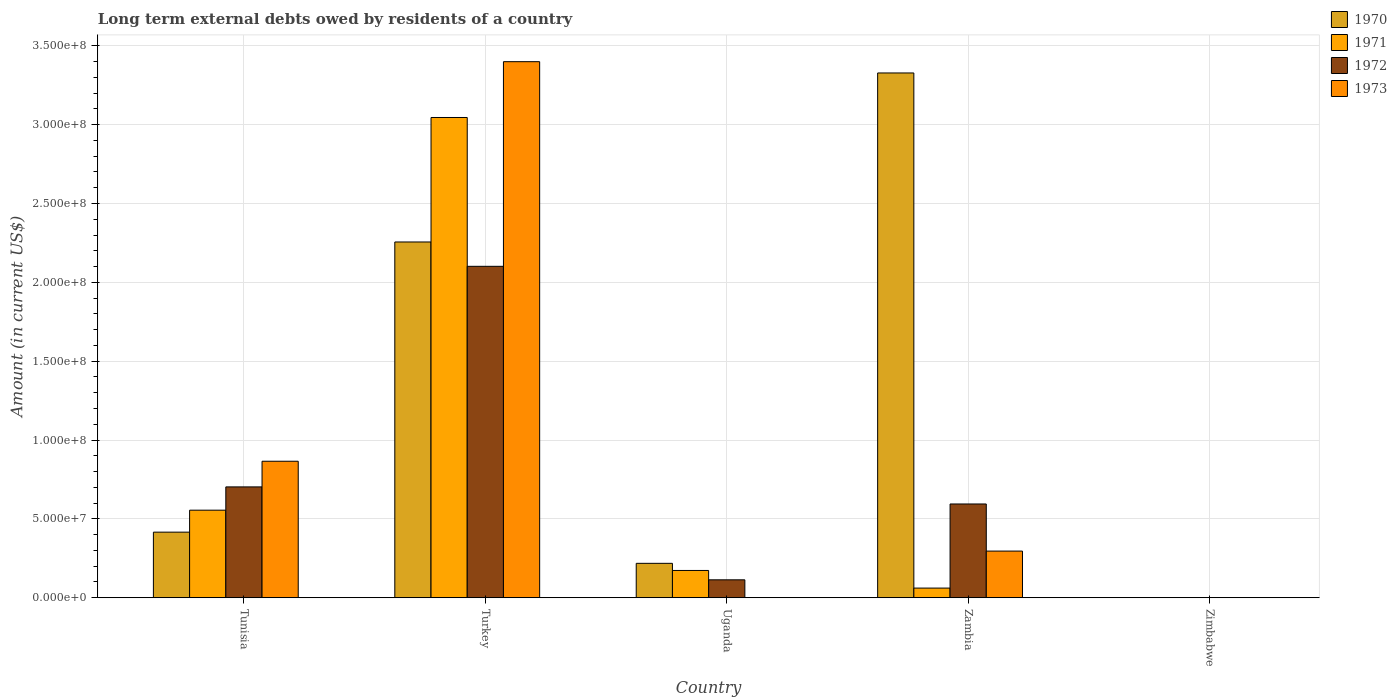How many different coloured bars are there?
Keep it short and to the point. 4. How many bars are there on the 3rd tick from the right?
Your response must be concise. 3. What is the label of the 5th group of bars from the left?
Make the answer very short. Zimbabwe. In how many cases, is the number of bars for a given country not equal to the number of legend labels?
Your answer should be very brief. 2. What is the amount of long-term external debts owed by residents in 1972 in Turkey?
Your answer should be very brief. 2.10e+08. Across all countries, what is the maximum amount of long-term external debts owed by residents in 1971?
Provide a short and direct response. 3.05e+08. Across all countries, what is the minimum amount of long-term external debts owed by residents in 1973?
Provide a short and direct response. 0. In which country was the amount of long-term external debts owed by residents in 1970 maximum?
Your response must be concise. Zambia. What is the total amount of long-term external debts owed by residents in 1971 in the graph?
Offer a terse response. 3.84e+08. What is the difference between the amount of long-term external debts owed by residents in 1972 in Uganda and that in Zambia?
Your answer should be compact. -4.81e+07. What is the difference between the amount of long-term external debts owed by residents in 1972 in Turkey and the amount of long-term external debts owed by residents in 1971 in Tunisia?
Your answer should be compact. 1.55e+08. What is the average amount of long-term external debts owed by residents in 1972 per country?
Offer a terse response. 7.03e+07. What is the difference between the amount of long-term external debts owed by residents of/in 1973 and amount of long-term external debts owed by residents of/in 1972 in Zambia?
Ensure brevity in your answer.  -2.99e+07. In how many countries, is the amount of long-term external debts owed by residents in 1973 greater than 220000000 US$?
Ensure brevity in your answer.  1. What is the ratio of the amount of long-term external debts owed by residents in 1971 in Turkey to that in Uganda?
Offer a very short reply. 17.6. Is the difference between the amount of long-term external debts owed by residents in 1973 in Tunisia and Turkey greater than the difference between the amount of long-term external debts owed by residents in 1972 in Tunisia and Turkey?
Keep it short and to the point. No. What is the difference between the highest and the second highest amount of long-term external debts owed by residents in 1971?
Make the answer very short. 2.87e+08. What is the difference between the highest and the lowest amount of long-term external debts owed by residents in 1971?
Provide a short and direct response. 3.05e+08. Is the sum of the amount of long-term external debts owed by residents in 1970 in Turkey and Uganda greater than the maximum amount of long-term external debts owed by residents in 1972 across all countries?
Your answer should be very brief. Yes. Is it the case that in every country, the sum of the amount of long-term external debts owed by residents in 1970 and amount of long-term external debts owed by residents in 1971 is greater than the sum of amount of long-term external debts owed by residents in 1972 and amount of long-term external debts owed by residents in 1973?
Offer a very short reply. No. Is it the case that in every country, the sum of the amount of long-term external debts owed by residents in 1973 and amount of long-term external debts owed by residents in 1971 is greater than the amount of long-term external debts owed by residents in 1970?
Make the answer very short. No. How many bars are there?
Your answer should be compact. 15. Are all the bars in the graph horizontal?
Provide a succinct answer. No. Does the graph contain grids?
Your answer should be very brief. Yes. How are the legend labels stacked?
Ensure brevity in your answer.  Vertical. What is the title of the graph?
Your answer should be compact. Long term external debts owed by residents of a country. Does "2001" appear as one of the legend labels in the graph?
Ensure brevity in your answer.  No. What is the label or title of the X-axis?
Your response must be concise. Country. What is the Amount (in current US$) in 1970 in Tunisia?
Give a very brief answer. 4.16e+07. What is the Amount (in current US$) in 1971 in Tunisia?
Provide a succinct answer. 5.55e+07. What is the Amount (in current US$) in 1972 in Tunisia?
Your answer should be very brief. 7.03e+07. What is the Amount (in current US$) in 1973 in Tunisia?
Your answer should be compact. 8.66e+07. What is the Amount (in current US$) in 1970 in Turkey?
Keep it short and to the point. 2.26e+08. What is the Amount (in current US$) in 1971 in Turkey?
Offer a terse response. 3.05e+08. What is the Amount (in current US$) in 1972 in Turkey?
Provide a succinct answer. 2.10e+08. What is the Amount (in current US$) of 1973 in Turkey?
Your response must be concise. 3.40e+08. What is the Amount (in current US$) in 1970 in Uganda?
Ensure brevity in your answer.  2.18e+07. What is the Amount (in current US$) of 1971 in Uganda?
Offer a terse response. 1.73e+07. What is the Amount (in current US$) in 1972 in Uganda?
Your answer should be compact. 1.14e+07. What is the Amount (in current US$) of 1973 in Uganda?
Ensure brevity in your answer.  0. What is the Amount (in current US$) of 1970 in Zambia?
Provide a short and direct response. 3.33e+08. What is the Amount (in current US$) of 1971 in Zambia?
Your answer should be compact. 6.13e+06. What is the Amount (in current US$) in 1972 in Zambia?
Your answer should be compact. 5.95e+07. What is the Amount (in current US$) of 1973 in Zambia?
Provide a succinct answer. 2.96e+07. What is the Amount (in current US$) of 1970 in Zimbabwe?
Your response must be concise. 0. What is the Amount (in current US$) in 1972 in Zimbabwe?
Provide a succinct answer. 0. Across all countries, what is the maximum Amount (in current US$) in 1970?
Your answer should be very brief. 3.33e+08. Across all countries, what is the maximum Amount (in current US$) in 1971?
Make the answer very short. 3.05e+08. Across all countries, what is the maximum Amount (in current US$) in 1972?
Ensure brevity in your answer.  2.10e+08. Across all countries, what is the maximum Amount (in current US$) in 1973?
Provide a succinct answer. 3.40e+08. Across all countries, what is the minimum Amount (in current US$) in 1970?
Make the answer very short. 0. Across all countries, what is the minimum Amount (in current US$) in 1971?
Keep it short and to the point. 0. Across all countries, what is the minimum Amount (in current US$) in 1972?
Offer a terse response. 0. What is the total Amount (in current US$) in 1970 in the graph?
Your answer should be very brief. 6.22e+08. What is the total Amount (in current US$) of 1971 in the graph?
Provide a succinct answer. 3.84e+08. What is the total Amount (in current US$) of 1972 in the graph?
Your answer should be very brief. 3.51e+08. What is the total Amount (in current US$) in 1973 in the graph?
Give a very brief answer. 4.56e+08. What is the difference between the Amount (in current US$) in 1970 in Tunisia and that in Turkey?
Offer a terse response. -1.84e+08. What is the difference between the Amount (in current US$) in 1971 in Tunisia and that in Turkey?
Offer a terse response. -2.49e+08. What is the difference between the Amount (in current US$) in 1972 in Tunisia and that in Turkey?
Offer a terse response. -1.40e+08. What is the difference between the Amount (in current US$) in 1973 in Tunisia and that in Turkey?
Ensure brevity in your answer.  -2.53e+08. What is the difference between the Amount (in current US$) of 1970 in Tunisia and that in Uganda?
Offer a very short reply. 1.98e+07. What is the difference between the Amount (in current US$) of 1971 in Tunisia and that in Uganda?
Provide a succinct answer. 3.82e+07. What is the difference between the Amount (in current US$) of 1972 in Tunisia and that in Uganda?
Your answer should be compact. 5.89e+07. What is the difference between the Amount (in current US$) of 1970 in Tunisia and that in Zambia?
Your answer should be very brief. -2.91e+08. What is the difference between the Amount (in current US$) of 1971 in Tunisia and that in Zambia?
Your response must be concise. 4.94e+07. What is the difference between the Amount (in current US$) of 1972 in Tunisia and that in Zambia?
Make the answer very short. 1.08e+07. What is the difference between the Amount (in current US$) of 1973 in Tunisia and that in Zambia?
Provide a succinct answer. 5.70e+07. What is the difference between the Amount (in current US$) of 1970 in Turkey and that in Uganda?
Give a very brief answer. 2.04e+08. What is the difference between the Amount (in current US$) in 1971 in Turkey and that in Uganda?
Your answer should be very brief. 2.87e+08. What is the difference between the Amount (in current US$) of 1972 in Turkey and that in Uganda?
Give a very brief answer. 1.99e+08. What is the difference between the Amount (in current US$) of 1970 in Turkey and that in Zambia?
Keep it short and to the point. -1.07e+08. What is the difference between the Amount (in current US$) of 1971 in Turkey and that in Zambia?
Provide a short and direct response. 2.98e+08. What is the difference between the Amount (in current US$) in 1972 in Turkey and that in Zambia?
Ensure brevity in your answer.  1.51e+08. What is the difference between the Amount (in current US$) of 1973 in Turkey and that in Zambia?
Your answer should be very brief. 3.10e+08. What is the difference between the Amount (in current US$) of 1970 in Uganda and that in Zambia?
Make the answer very short. -3.11e+08. What is the difference between the Amount (in current US$) of 1971 in Uganda and that in Zambia?
Make the answer very short. 1.12e+07. What is the difference between the Amount (in current US$) of 1972 in Uganda and that in Zambia?
Your response must be concise. -4.81e+07. What is the difference between the Amount (in current US$) of 1970 in Tunisia and the Amount (in current US$) of 1971 in Turkey?
Your response must be concise. -2.63e+08. What is the difference between the Amount (in current US$) in 1970 in Tunisia and the Amount (in current US$) in 1972 in Turkey?
Keep it short and to the point. -1.69e+08. What is the difference between the Amount (in current US$) of 1970 in Tunisia and the Amount (in current US$) of 1973 in Turkey?
Keep it short and to the point. -2.98e+08. What is the difference between the Amount (in current US$) of 1971 in Tunisia and the Amount (in current US$) of 1972 in Turkey?
Provide a succinct answer. -1.55e+08. What is the difference between the Amount (in current US$) in 1971 in Tunisia and the Amount (in current US$) in 1973 in Turkey?
Your response must be concise. -2.84e+08. What is the difference between the Amount (in current US$) in 1972 in Tunisia and the Amount (in current US$) in 1973 in Turkey?
Offer a terse response. -2.70e+08. What is the difference between the Amount (in current US$) in 1970 in Tunisia and the Amount (in current US$) in 1971 in Uganda?
Provide a short and direct response. 2.43e+07. What is the difference between the Amount (in current US$) of 1970 in Tunisia and the Amount (in current US$) of 1972 in Uganda?
Your response must be concise. 3.02e+07. What is the difference between the Amount (in current US$) of 1971 in Tunisia and the Amount (in current US$) of 1972 in Uganda?
Ensure brevity in your answer.  4.42e+07. What is the difference between the Amount (in current US$) in 1970 in Tunisia and the Amount (in current US$) in 1971 in Zambia?
Keep it short and to the point. 3.55e+07. What is the difference between the Amount (in current US$) of 1970 in Tunisia and the Amount (in current US$) of 1972 in Zambia?
Make the answer very short. -1.79e+07. What is the difference between the Amount (in current US$) of 1970 in Tunisia and the Amount (in current US$) of 1973 in Zambia?
Make the answer very short. 1.20e+07. What is the difference between the Amount (in current US$) of 1971 in Tunisia and the Amount (in current US$) of 1972 in Zambia?
Provide a short and direct response. -3.93e+06. What is the difference between the Amount (in current US$) of 1971 in Tunisia and the Amount (in current US$) of 1973 in Zambia?
Give a very brief answer. 2.59e+07. What is the difference between the Amount (in current US$) in 1972 in Tunisia and the Amount (in current US$) in 1973 in Zambia?
Make the answer very short. 4.07e+07. What is the difference between the Amount (in current US$) of 1970 in Turkey and the Amount (in current US$) of 1971 in Uganda?
Provide a short and direct response. 2.08e+08. What is the difference between the Amount (in current US$) in 1970 in Turkey and the Amount (in current US$) in 1972 in Uganda?
Make the answer very short. 2.14e+08. What is the difference between the Amount (in current US$) of 1971 in Turkey and the Amount (in current US$) of 1972 in Uganda?
Your response must be concise. 2.93e+08. What is the difference between the Amount (in current US$) in 1970 in Turkey and the Amount (in current US$) in 1971 in Zambia?
Offer a terse response. 2.19e+08. What is the difference between the Amount (in current US$) of 1970 in Turkey and the Amount (in current US$) of 1972 in Zambia?
Make the answer very short. 1.66e+08. What is the difference between the Amount (in current US$) in 1970 in Turkey and the Amount (in current US$) in 1973 in Zambia?
Keep it short and to the point. 1.96e+08. What is the difference between the Amount (in current US$) of 1971 in Turkey and the Amount (in current US$) of 1972 in Zambia?
Provide a short and direct response. 2.45e+08. What is the difference between the Amount (in current US$) in 1971 in Turkey and the Amount (in current US$) in 1973 in Zambia?
Your response must be concise. 2.75e+08. What is the difference between the Amount (in current US$) of 1972 in Turkey and the Amount (in current US$) of 1973 in Zambia?
Provide a succinct answer. 1.81e+08. What is the difference between the Amount (in current US$) in 1970 in Uganda and the Amount (in current US$) in 1971 in Zambia?
Your answer should be compact. 1.57e+07. What is the difference between the Amount (in current US$) of 1970 in Uganda and the Amount (in current US$) of 1972 in Zambia?
Ensure brevity in your answer.  -3.76e+07. What is the difference between the Amount (in current US$) of 1970 in Uganda and the Amount (in current US$) of 1973 in Zambia?
Offer a very short reply. -7.76e+06. What is the difference between the Amount (in current US$) in 1971 in Uganda and the Amount (in current US$) in 1972 in Zambia?
Ensure brevity in your answer.  -4.22e+07. What is the difference between the Amount (in current US$) of 1971 in Uganda and the Amount (in current US$) of 1973 in Zambia?
Offer a very short reply. -1.23e+07. What is the difference between the Amount (in current US$) of 1972 in Uganda and the Amount (in current US$) of 1973 in Zambia?
Offer a very short reply. -1.82e+07. What is the average Amount (in current US$) of 1970 per country?
Make the answer very short. 1.24e+08. What is the average Amount (in current US$) of 1971 per country?
Make the answer very short. 7.67e+07. What is the average Amount (in current US$) in 1972 per country?
Keep it short and to the point. 7.03e+07. What is the average Amount (in current US$) in 1973 per country?
Ensure brevity in your answer.  9.12e+07. What is the difference between the Amount (in current US$) in 1970 and Amount (in current US$) in 1971 in Tunisia?
Give a very brief answer. -1.39e+07. What is the difference between the Amount (in current US$) in 1970 and Amount (in current US$) in 1972 in Tunisia?
Your answer should be compact. -2.87e+07. What is the difference between the Amount (in current US$) of 1970 and Amount (in current US$) of 1973 in Tunisia?
Offer a very short reply. -4.50e+07. What is the difference between the Amount (in current US$) of 1971 and Amount (in current US$) of 1972 in Tunisia?
Your response must be concise. -1.48e+07. What is the difference between the Amount (in current US$) in 1971 and Amount (in current US$) in 1973 in Tunisia?
Your response must be concise. -3.10e+07. What is the difference between the Amount (in current US$) of 1972 and Amount (in current US$) of 1973 in Tunisia?
Offer a very short reply. -1.63e+07. What is the difference between the Amount (in current US$) of 1970 and Amount (in current US$) of 1971 in Turkey?
Provide a succinct answer. -7.89e+07. What is the difference between the Amount (in current US$) in 1970 and Amount (in current US$) in 1972 in Turkey?
Provide a short and direct response. 1.54e+07. What is the difference between the Amount (in current US$) in 1970 and Amount (in current US$) in 1973 in Turkey?
Your answer should be compact. -1.14e+08. What is the difference between the Amount (in current US$) of 1971 and Amount (in current US$) of 1972 in Turkey?
Your answer should be compact. 9.44e+07. What is the difference between the Amount (in current US$) in 1971 and Amount (in current US$) in 1973 in Turkey?
Ensure brevity in your answer.  -3.54e+07. What is the difference between the Amount (in current US$) in 1972 and Amount (in current US$) in 1973 in Turkey?
Offer a terse response. -1.30e+08. What is the difference between the Amount (in current US$) in 1970 and Amount (in current US$) in 1971 in Uganda?
Provide a short and direct response. 4.52e+06. What is the difference between the Amount (in current US$) in 1970 and Amount (in current US$) in 1972 in Uganda?
Your answer should be very brief. 1.05e+07. What is the difference between the Amount (in current US$) of 1971 and Amount (in current US$) of 1972 in Uganda?
Offer a very short reply. 5.94e+06. What is the difference between the Amount (in current US$) of 1970 and Amount (in current US$) of 1971 in Zambia?
Ensure brevity in your answer.  3.27e+08. What is the difference between the Amount (in current US$) in 1970 and Amount (in current US$) in 1972 in Zambia?
Your answer should be very brief. 2.73e+08. What is the difference between the Amount (in current US$) of 1970 and Amount (in current US$) of 1973 in Zambia?
Provide a succinct answer. 3.03e+08. What is the difference between the Amount (in current US$) of 1971 and Amount (in current US$) of 1972 in Zambia?
Provide a succinct answer. -5.33e+07. What is the difference between the Amount (in current US$) in 1971 and Amount (in current US$) in 1973 in Zambia?
Offer a very short reply. -2.35e+07. What is the difference between the Amount (in current US$) in 1972 and Amount (in current US$) in 1973 in Zambia?
Give a very brief answer. 2.99e+07. What is the ratio of the Amount (in current US$) of 1970 in Tunisia to that in Turkey?
Your answer should be compact. 0.18. What is the ratio of the Amount (in current US$) of 1971 in Tunisia to that in Turkey?
Ensure brevity in your answer.  0.18. What is the ratio of the Amount (in current US$) of 1972 in Tunisia to that in Turkey?
Give a very brief answer. 0.33. What is the ratio of the Amount (in current US$) in 1973 in Tunisia to that in Turkey?
Give a very brief answer. 0.25. What is the ratio of the Amount (in current US$) in 1970 in Tunisia to that in Uganda?
Offer a terse response. 1.91. What is the ratio of the Amount (in current US$) of 1971 in Tunisia to that in Uganda?
Ensure brevity in your answer.  3.21. What is the ratio of the Amount (in current US$) in 1972 in Tunisia to that in Uganda?
Make the answer very short. 6.19. What is the ratio of the Amount (in current US$) in 1970 in Tunisia to that in Zambia?
Give a very brief answer. 0.12. What is the ratio of the Amount (in current US$) in 1971 in Tunisia to that in Zambia?
Give a very brief answer. 9.06. What is the ratio of the Amount (in current US$) in 1972 in Tunisia to that in Zambia?
Your answer should be very brief. 1.18. What is the ratio of the Amount (in current US$) in 1973 in Tunisia to that in Zambia?
Your answer should be compact. 2.93. What is the ratio of the Amount (in current US$) of 1970 in Turkey to that in Uganda?
Keep it short and to the point. 10.34. What is the ratio of the Amount (in current US$) of 1971 in Turkey to that in Uganda?
Offer a terse response. 17.6. What is the ratio of the Amount (in current US$) in 1972 in Turkey to that in Uganda?
Provide a short and direct response. 18.49. What is the ratio of the Amount (in current US$) in 1970 in Turkey to that in Zambia?
Make the answer very short. 0.68. What is the ratio of the Amount (in current US$) of 1971 in Turkey to that in Zambia?
Provide a short and direct response. 49.68. What is the ratio of the Amount (in current US$) in 1972 in Turkey to that in Zambia?
Make the answer very short. 3.53. What is the ratio of the Amount (in current US$) in 1973 in Turkey to that in Zambia?
Give a very brief answer. 11.49. What is the ratio of the Amount (in current US$) in 1970 in Uganda to that in Zambia?
Offer a very short reply. 0.07. What is the ratio of the Amount (in current US$) of 1971 in Uganda to that in Zambia?
Your response must be concise. 2.82. What is the ratio of the Amount (in current US$) of 1972 in Uganda to that in Zambia?
Give a very brief answer. 0.19. What is the difference between the highest and the second highest Amount (in current US$) in 1970?
Provide a succinct answer. 1.07e+08. What is the difference between the highest and the second highest Amount (in current US$) in 1971?
Offer a terse response. 2.49e+08. What is the difference between the highest and the second highest Amount (in current US$) of 1972?
Keep it short and to the point. 1.40e+08. What is the difference between the highest and the second highest Amount (in current US$) in 1973?
Your answer should be very brief. 2.53e+08. What is the difference between the highest and the lowest Amount (in current US$) of 1970?
Your answer should be very brief. 3.33e+08. What is the difference between the highest and the lowest Amount (in current US$) of 1971?
Provide a short and direct response. 3.05e+08. What is the difference between the highest and the lowest Amount (in current US$) in 1972?
Offer a terse response. 2.10e+08. What is the difference between the highest and the lowest Amount (in current US$) of 1973?
Offer a terse response. 3.40e+08. 